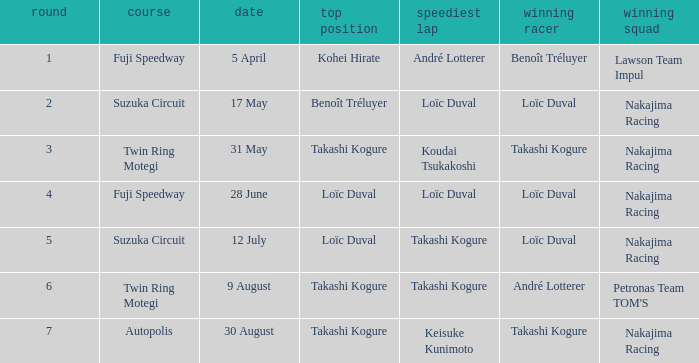Who was the driver for the winning team Lawson Team Impul? Benoît Tréluyer. 